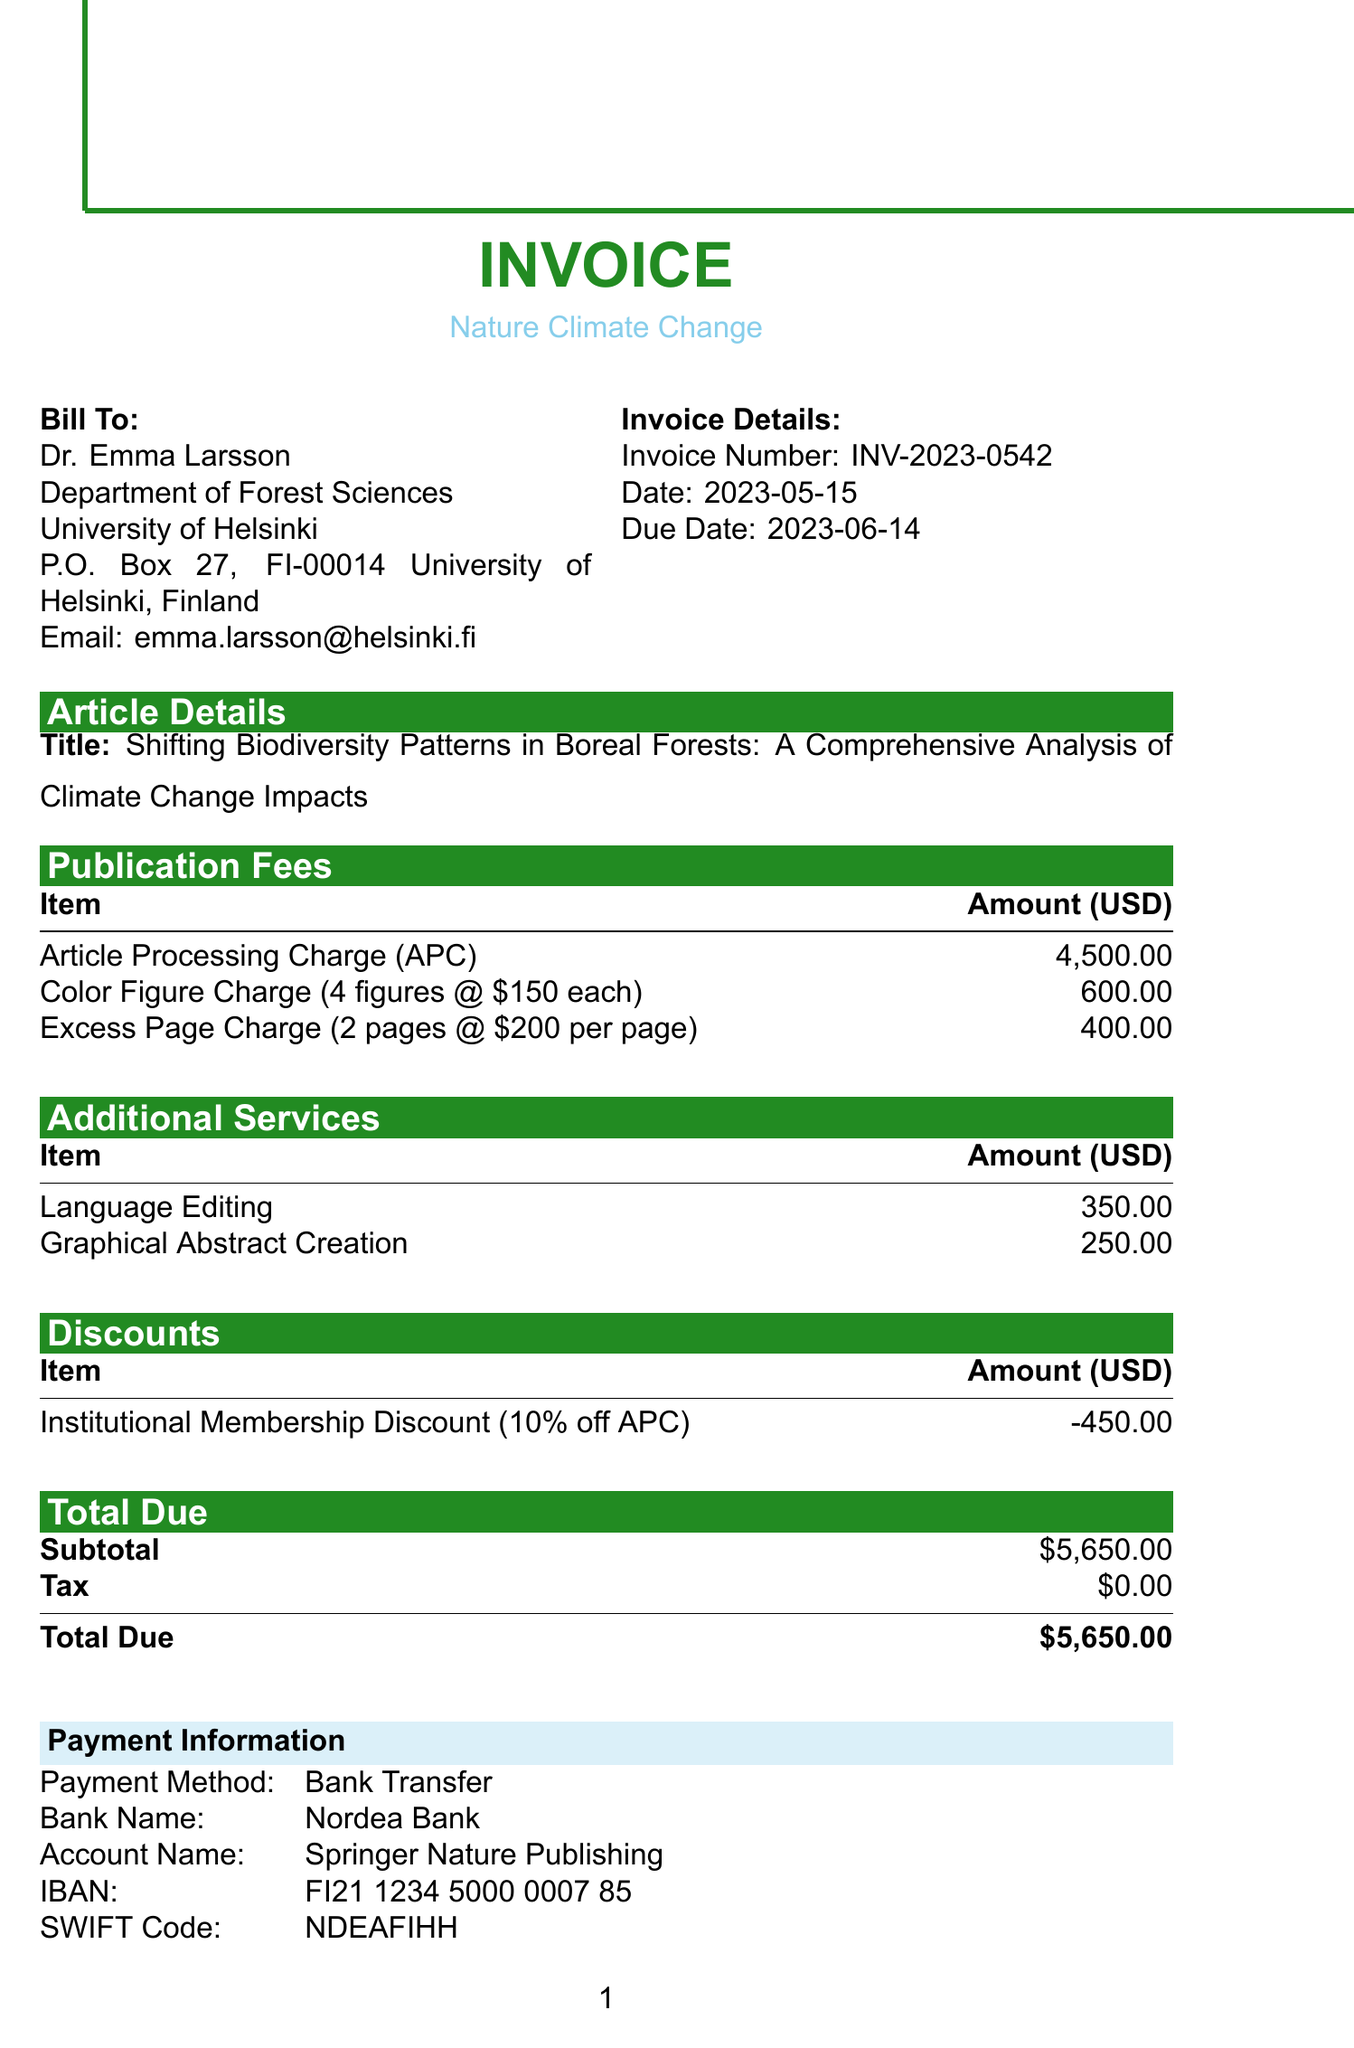What is the invoice number? The invoice number is clearly stated in the document under invoice details.
Answer: INV-2023-0542 Who is the author of the paper? The author's name is mentioned in the author details section of the document.
Answer: Dr. Emma Larsson What is the total due amount? The total due amount is provided in the total due section of the document.
Answer: $5,650.00 What is the publication date? The expected publication date is located in the additional information section of the document.
Answer: 2023-07-15 What was the discount applied? The discount information is listed under discounts in the document.
Answer: Institutional Membership Discount How much was charged for language editing? The amount charged for language editing is specified in the additional services section.
Answer: $350.00 What method of payment is accepted? The payment method is indicated in the payment information section of the document.
Answer: Bank Transfer Where is the University of Helsinki located? The address of the University of Helsinki is provided in the author details section.
Answer: P.O. Box 27, FI-00014 University of Helsinki, Finland What is the accepted date of the manuscript? The accepted date is included in the additional information section of the document.
Answer: 2023-04-30 